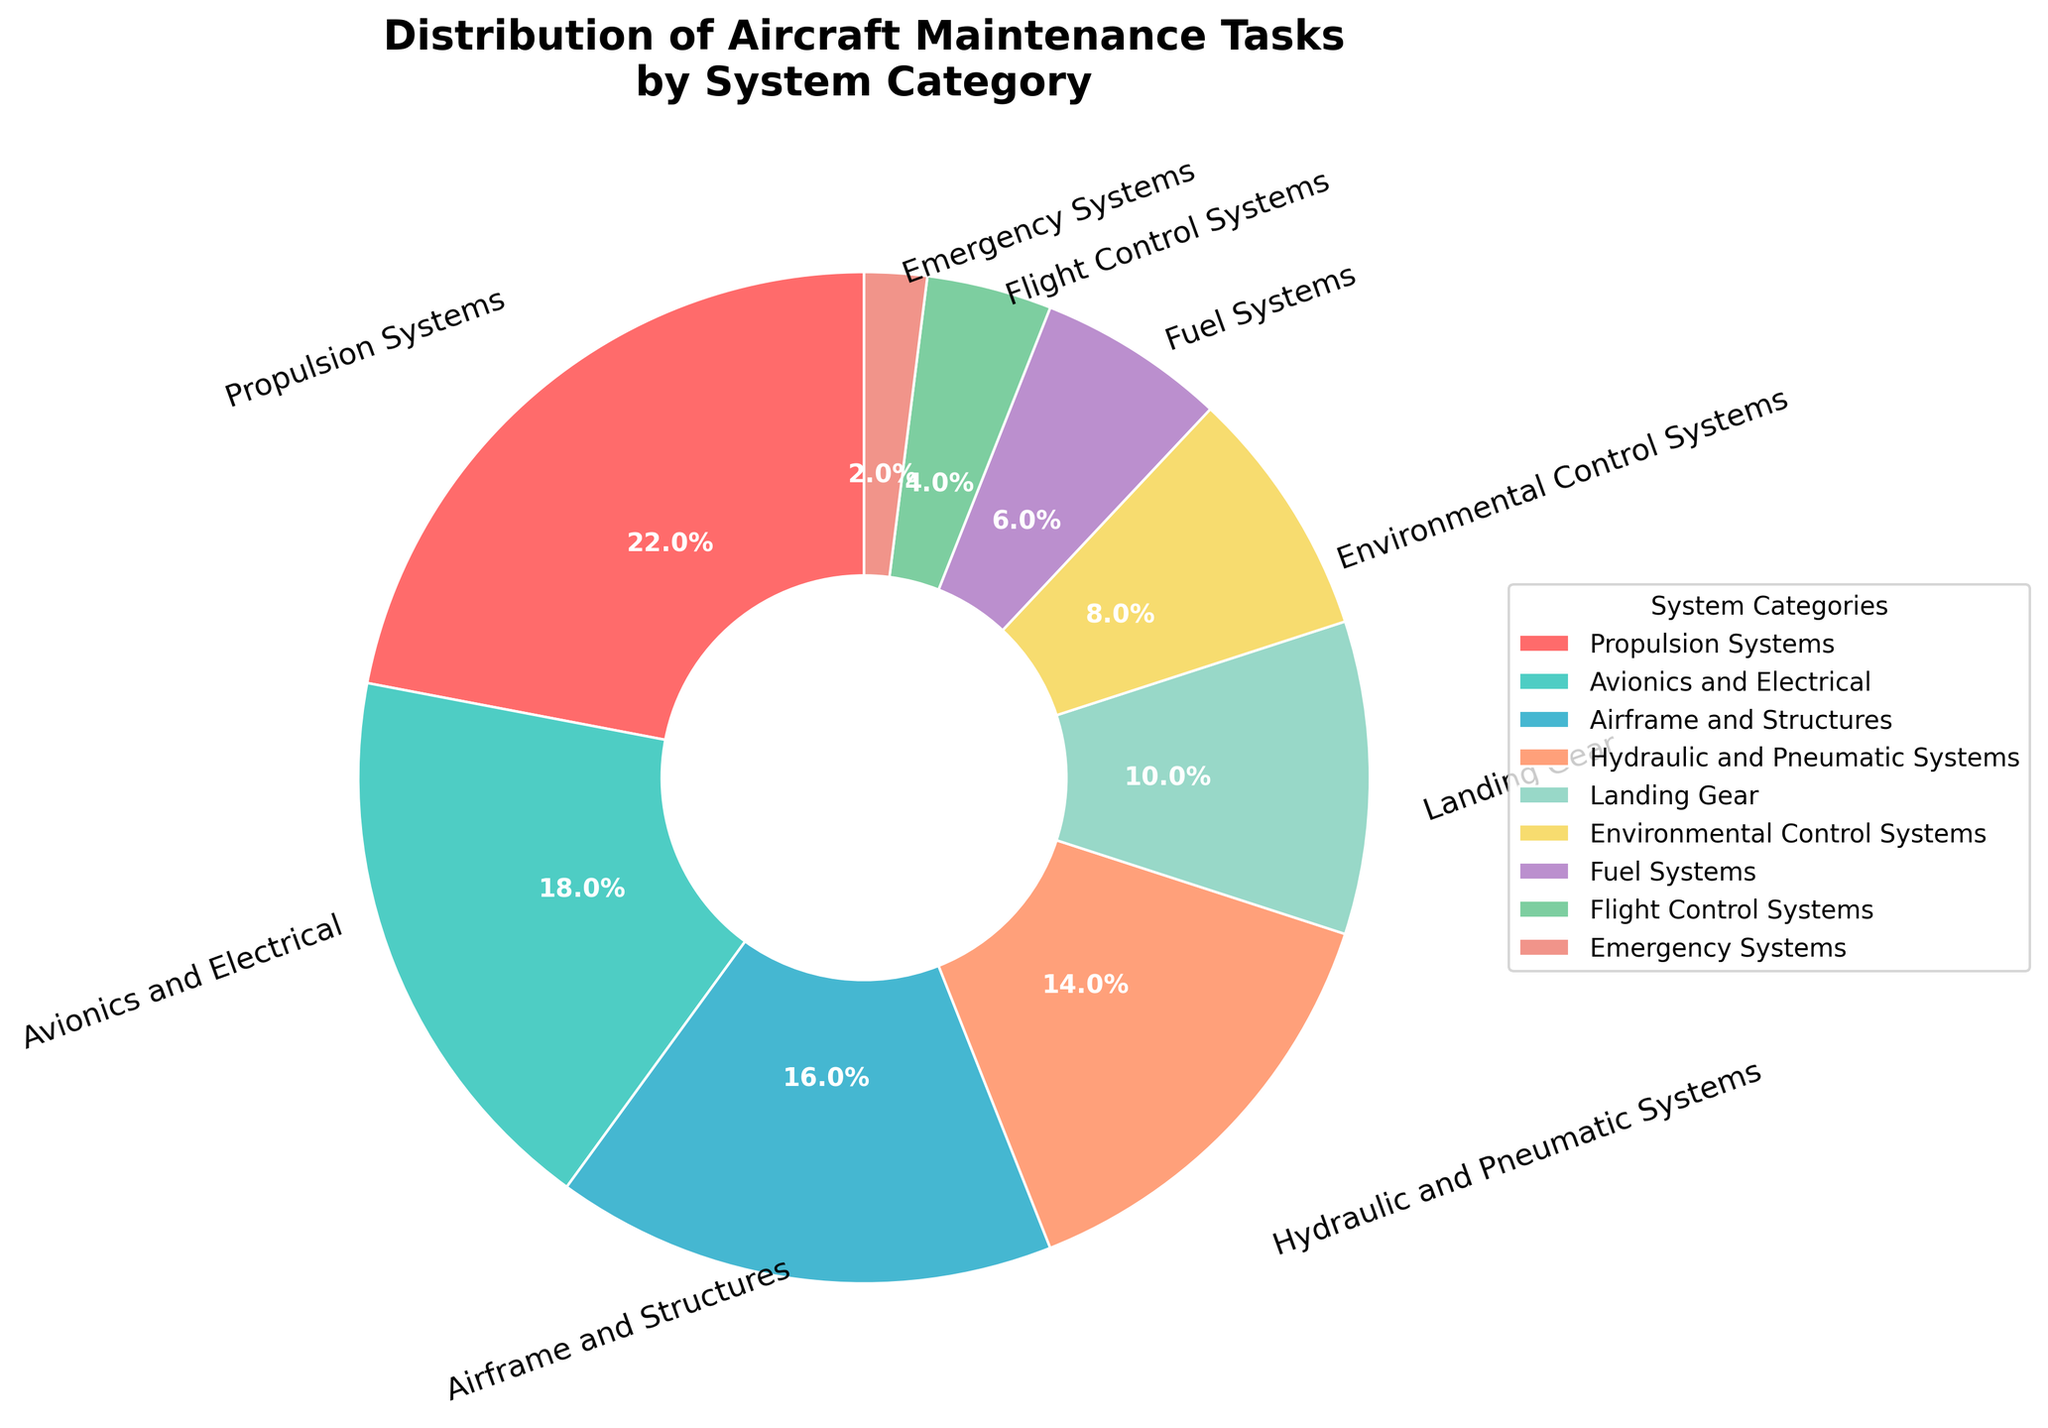Which system category has the highest percentage of maintenance tasks? Observe the pie chart and find the segment that represents the largest portion. The largest segment is labeled "Propulsion Systems" with 22%.
Answer: Propulsion Systems How much more is the percentage of Avionics and Electrical compared to Flight Control Systems? Subtract the percentage of Flight Control Systems from Avionics and Electrical. That is, \(18 - 4 = 14\).
Answer: 14 What is the combined percentage of maintenance tasks for Hydraulic and Pneumatic Systems and Landing Gear? Add the percentages for Hydraulic and Pneumatic Systems and Landing Gear. That is, \(14 + 10 = 24\).
Answer: 24 Which system categories have a smaller percentage than Environmental Control Systems? Identify categories with percentages smaller than 8%. The categories that fit this criterion are Fuel Systems (6%) and Emergency Systems (2%).
Answer: Fuel Systems, Emergency Systems What is the total percentage of maintenance tasks for categories with more than 10%? Sum the percentages of categories with more than 10%, which are Propulsion Systems (22%), Avionics and Electrical (18%), Airframe and Structures (16%), and Hydraulic and Pneumatic Systems (14%). That is, \(22 + 18 + 16 + 14 = 70\).
Answer: 70 Which system category has the smallest percentage of maintenance tasks? Observe the pie chart and find the segment that represents the smallest portion. The smallest segment is labeled "Emergency Systems" with 2%.
Answer: Emergency Systems Compare the percentage of Airframe and Structures to Environmental Control Systems. Which one is greater? Identify the percentages for both categories: Airframe and Structures (16%) and Environmental Control Systems (8%). The category with the higher percentage is Airframe and Structures.
Answer: Airframe and Structures What is the average percentage of the maintenance tasks for Propulsion Systems, Avionics and Electrical, and Airframe and Structures? Sum the percentages of the three categories and then divide by the number of categories. That is, \( 22 + 18 + 16 = 56 \) and \( 56 / 3 \approx 18.67 \).
Answer: 18.67 How does the percentage of Landing Gear compare to Fuel Systems on the pie chart? Identify the percentages for both categories: Landing Gear (10%) and Fuel Systems (6%). The category with the higher percentage is Landing Gear.
Answer: Landing Gear 